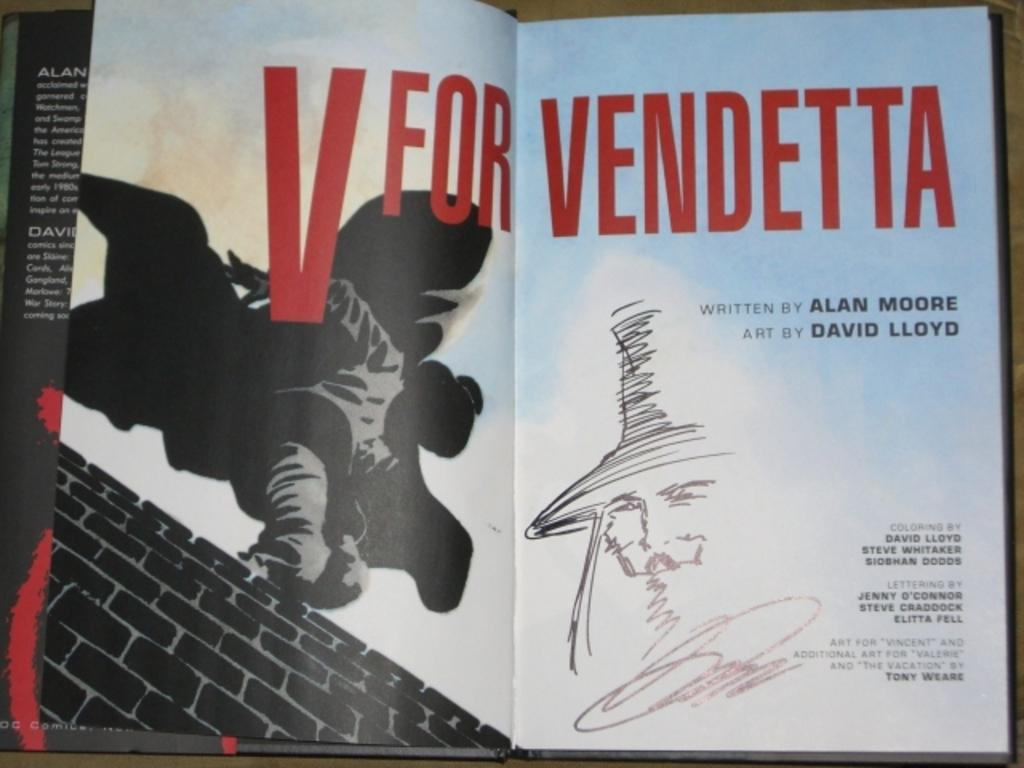<image>
Offer a succinct explanation of the picture presented. Open book that says, "V for Vendetta written by Alan Moore. 